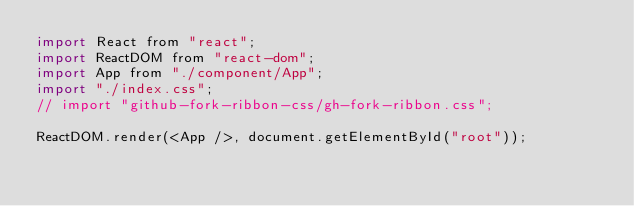<code> <loc_0><loc_0><loc_500><loc_500><_JavaScript_>import React from "react";
import ReactDOM from "react-dom";
import App from "./component/App";
import "./index.css";
// import "github-fork-ribbon-css/gh-fork-ribbon.css";

ReactDOM.render(<App />, document.getElementById("root"));
</code> 